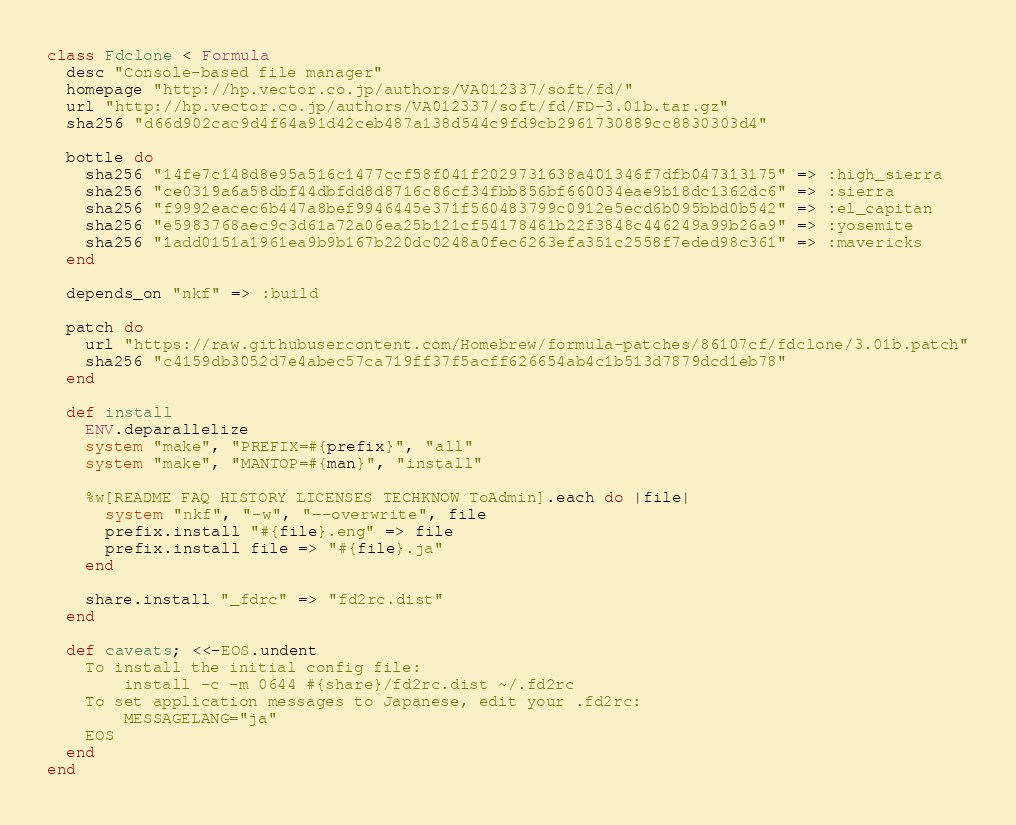<code> <loc_0><loc_0><loc_500><loc_500><_Ruby_>class Fdclone < Formula
  desc "Console-based file manager"
  homepage "http://hp.vector.co.jp/authors/VA012337/soft/fd/"
  url "http://hp.vector.co.jp/authors/VA012337/soft/fd/FD-3.01b.tar.gz"
  sha256 "d66d902cac9d4f64a91d42ceb487a138d544c9fd9cb2961730889cc8830303d4"

  bottle do
    sha256 "14fe7c148d8e95a516c1477ccf58f041f2029731638a401346f7dfb047313175" => :high_sierra
    sha256 "ce0319a6a58dbf44dbfdd8d8716c86cf34fbb856bf660034eae9b18dc1362dc6" => :sierra
    sha256 "f9992eacec6b447a8bef9946445e371f560483799c0912e5ecd6b095bbd0b542" => :el_capitan
    sha256 "e5983768aec9c3d61a72a06ea25b121cf54178461b22f3848c446249a99b26a9" => :yosemite
    sha256 "1add0151a1961ea9b9b167b220dc0248a0fec6263efa351c2558f7eded98c361" => :mavericks
  end

  depends_on "nkf" => :build

  patch do
    url "https://raw.githubusercontent.com/Homebrew/formula-patches/86107cf/fdclone/3.01b.patch"
    sha256 "c4159db3052d7e4abec57ca719ff37f5acff626654ab4c1b513d7879dcd1eb78"
  end

  def install
    ENV.deparallelize
    system "make", "PREFIX=#{prefix}", "all"
    system "make", "MANTOP=#{man}", "install"

    %w[README FAQ HISTORY LICENSES TECHKNOW ToAdmin].each do |file|
      system "nkf", "-w", "--overwrite", file
      prefix.install "#{file}.eng" => file
      prefix.install file => "#{file}.ja"
    end

    share.install "_fdrc" => "fd2rc.dist"
  end

  def caveats; <<-EOS.undent
    To install the initial config file:
        install -c -m 0644 #{share}/fd2rc.dist ~/.fd2rc
    To set application messages to Japanese, edit your .fd2rc:
        MESSAGELANG="ja"
    EOS
  end
end
</code> 